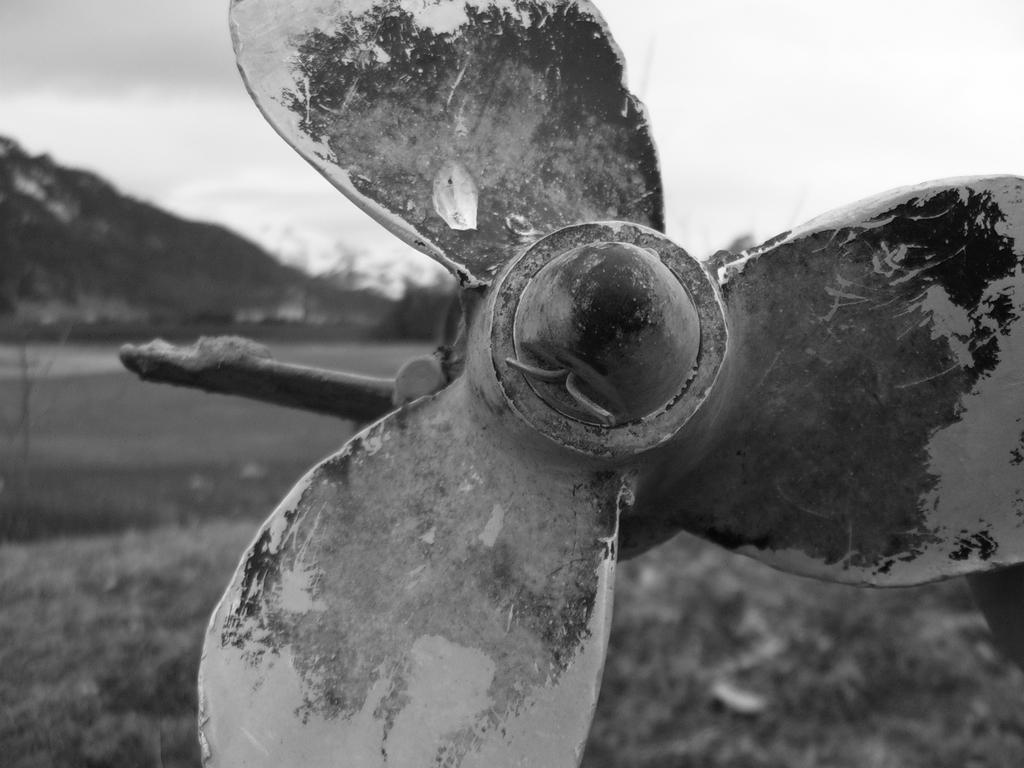What is the main object in the center of the image? There is a fan in the center of the image. What can be seen in the background of the image? Hills and the sky are visible in the background of the image. What type of shoes are the players wearing during the baseball game in the image? There is no baseball game or shoes present in the image; it features a fan and hills in the background. 